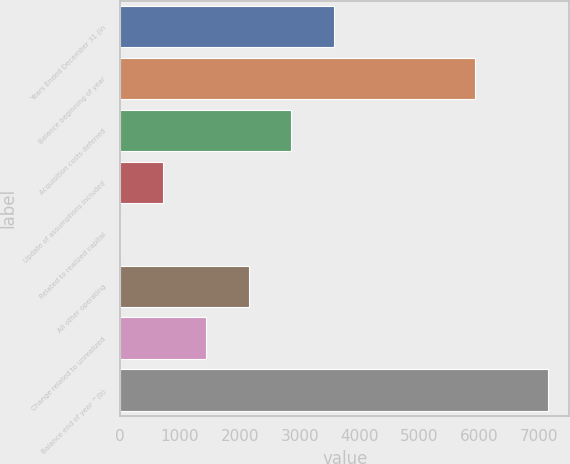<chart> <loc_0><loc_0><loc_500><loc_500><bar_chart><fcel>Years Ended December 31 (in<fcel>Balance beginning of year<fcel>Acquisition costs deferred<fcel>Update of assumptions included<fcel>Related to realized capital<fcel>All other operating<fcel>Change related to unrealized<fcel>Balance end of year ^(b)<nl><fcel>3575.5<fcel>5928<fcel>2860.8<fcel>716.7<fcel>2<fcel>2146.1<fcel>1431.4<fcel>7149<nl></chart> 